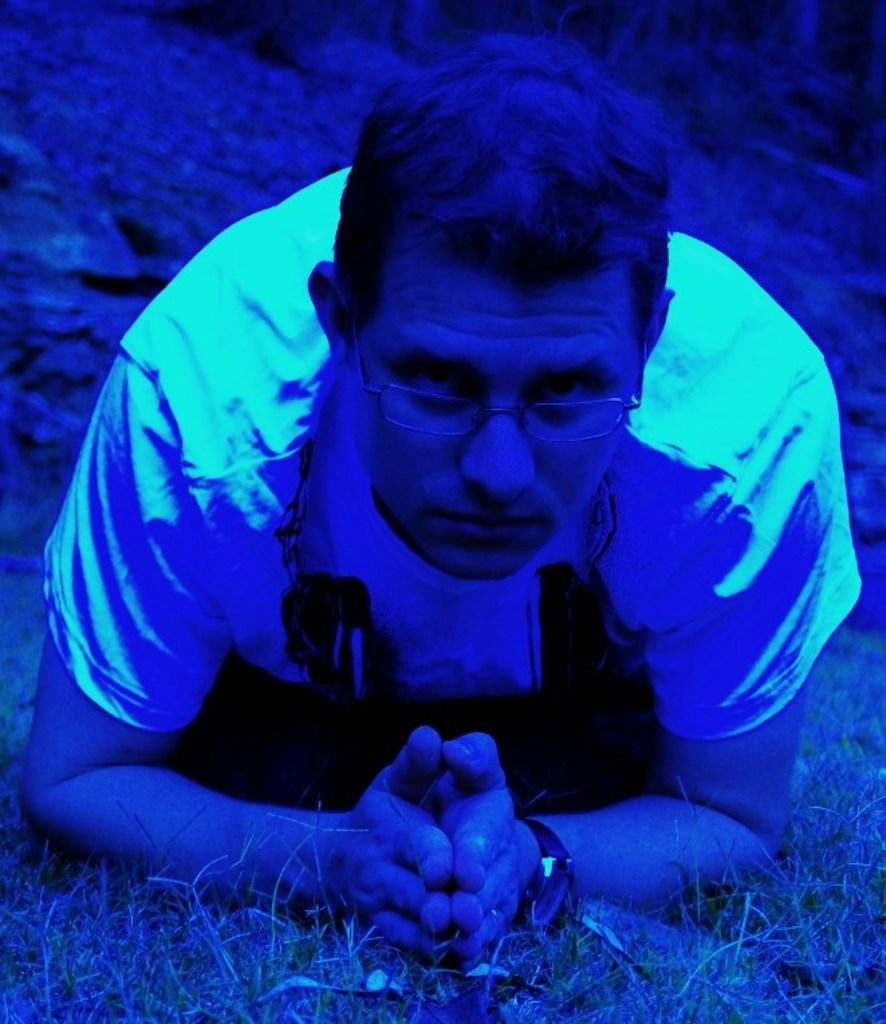Who or what is the main subject in the image? There is a person in the image. What can be observed about the person's appearance? The person is wearing spectacles and a t-shirt. Q:shirt. What type of surface is the person standing on in the image? There is grass beneath the person. What type of sound can be heard coming from the person's nail in the image? There is no nail present in the image, and therefore no sound can be heard coming from it. 